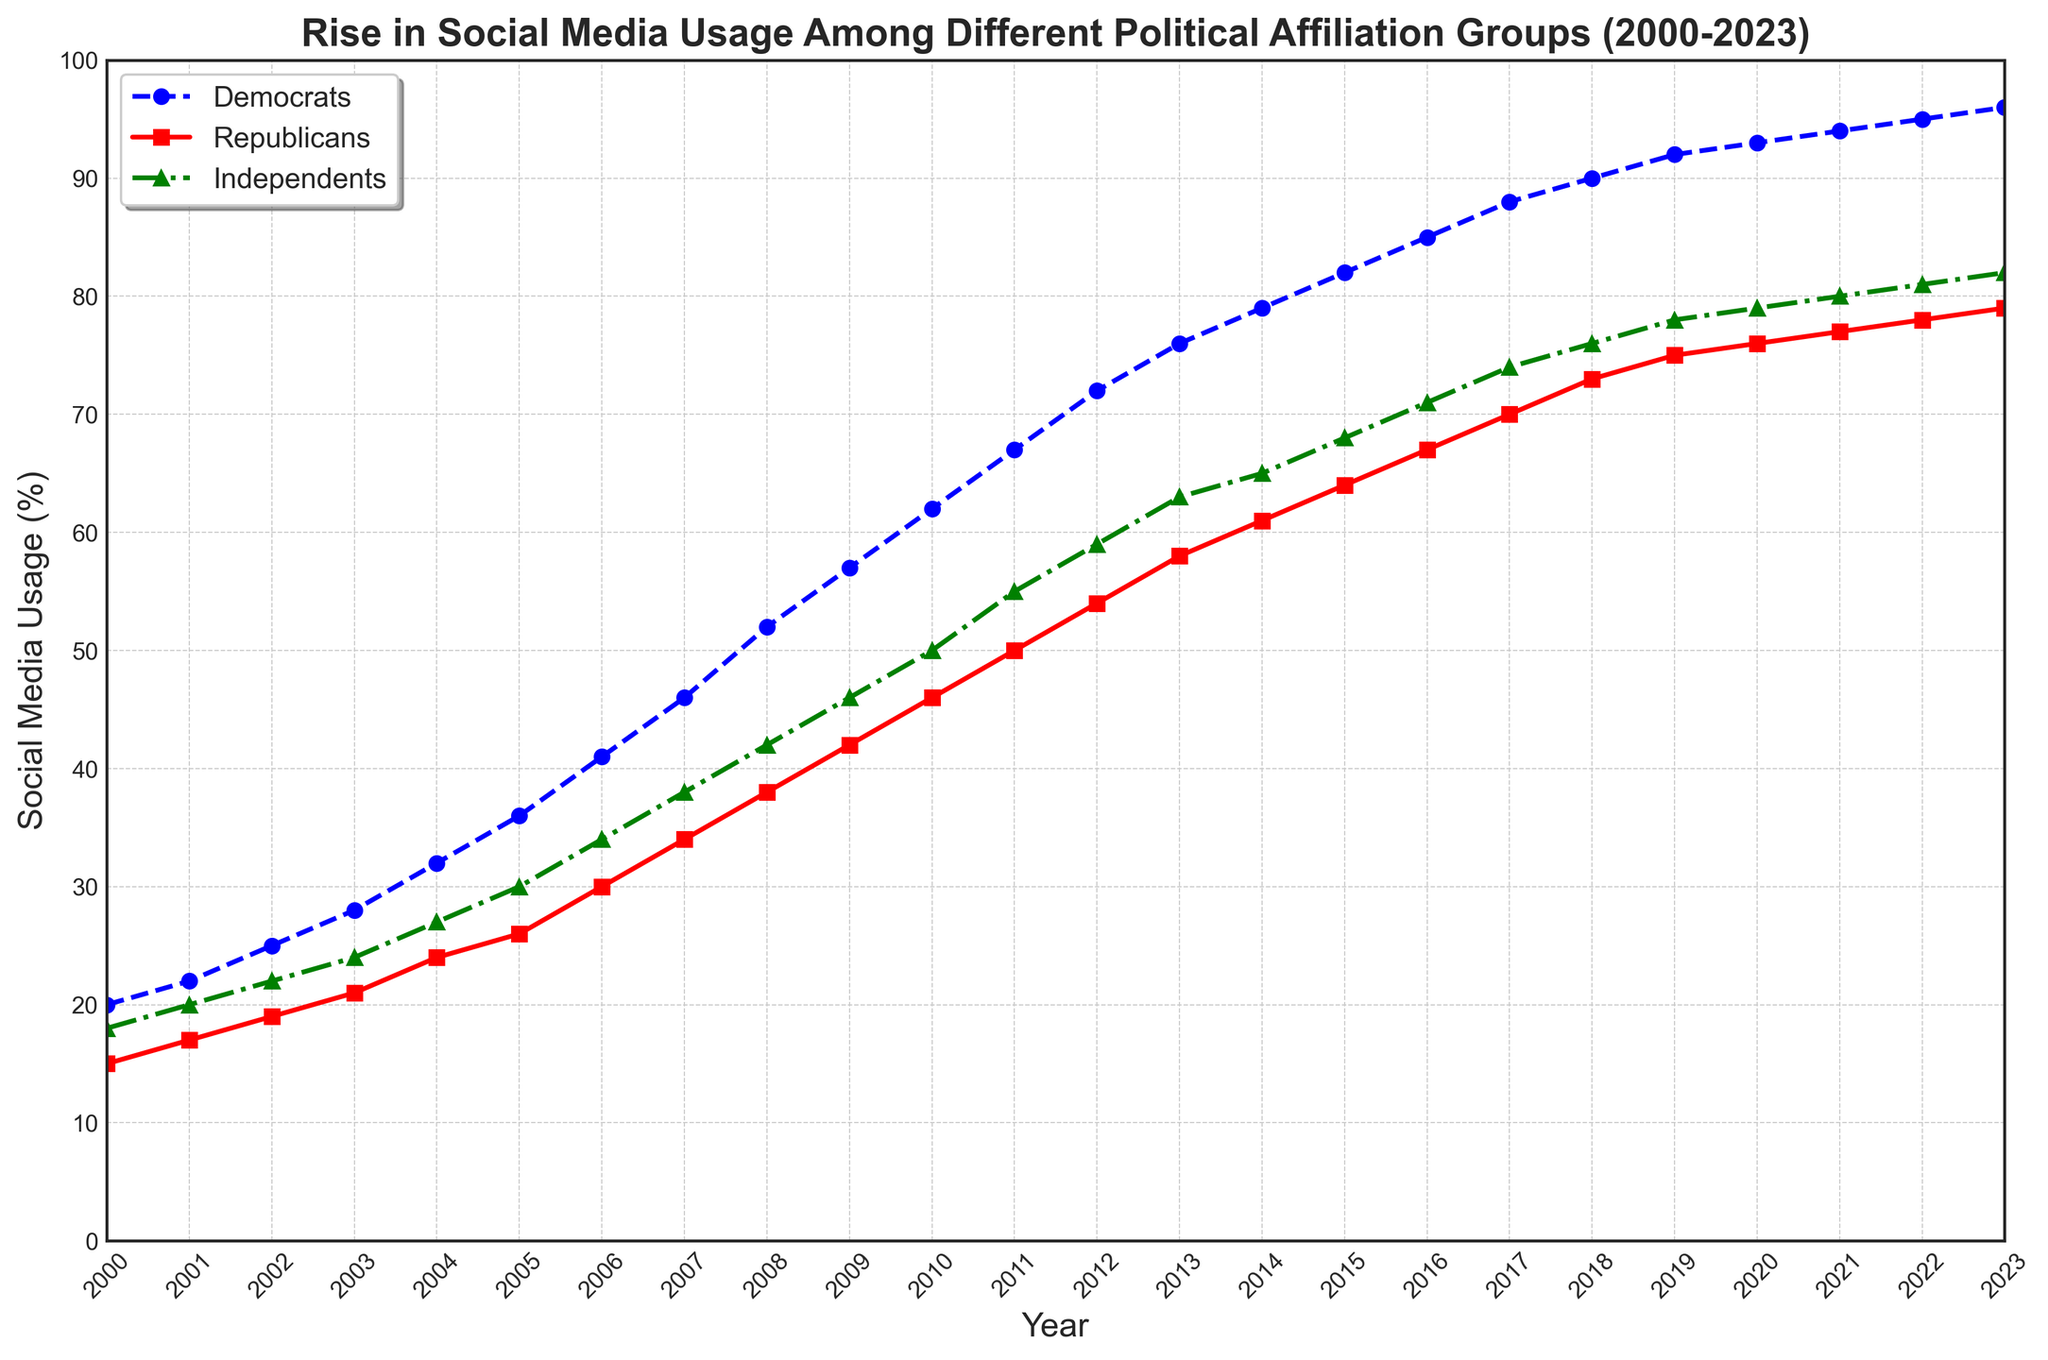What is the percentage increase in social media usage among Democrats from 2000 to 2023? To find the percentage increase, we need to calculate the difference in usage from 2000 to 2023 and then divide by the initial value. In 2000, the value is 20%, and in 2023, it's 96%. The increase is 96 - 20 = 76%. The percentage increase is (76 / 20) * 100 = 380%.
Answer: 380% In which year did Independents surpass a 50% social media usage rate? To find when Independents surpass 50%, we examine the values for each year. In 2011, the usage is 55%, which is the first time it is over 50%.
Answer: 2011 Between Democrats and Republicans, which group had a higher increase in social media usage from 2005 to 2015? We compare the increase for both groups between these years. For Democrats, in 2015 it is 82% and in 2005 it is 36%, so the increase is 82 - 36 = 46%. For Republicans, in 2015 it's 64% and in 2005 it is 26%, so the increase is 64 - 26 = 38%. Democrats have a higher increase.
Answer: Democrats What was the average social media usage of Republicans from 2000 to 2010? Calculate the average usage over the specified years. Sum the values (15 + 17 + 19 + 21 + 24 + 26 + 30 + 34 + 38 + 42 + 46) = 312, then divide by the number of years, 11. The average is 312 / 11 = 28.36%.
Answer: 28.36% How does the social media usage of Independents in 2020 compare to that in 2005? To compare, subtract the 2005 value from the 2020 value. In 2020 it's 79%, and in 2005 it's 30%. The difference is 79 - 30 = 49%.
Answer: 49% higher In which year did the Democrats reach social media usage of 70% or more? We need to find the first year when Democrats' usage is 70% or higher. In 2012, the value is 72%, meeting the criteria.
Answer: 2012 For which political group was the increase in social media usage from 2015 to 2023 the smallest? Calculate the increase for each group from 2015 to 2023. For Democrats: 96% - 82% = 14%. For Republicans: 79% - 64% = 15%. For Independents: 82% - 68% = 14%. Both Democrats and Independents had the smallest increase.
Answer: Democrats and Independents What was the difference in social media usage between Republicans and Independents in 2018? Subtract the percentage usage of Republicans from Independents for 2018. Independents' usage in 2018 is 76%, and Republicans' usage is 73%. The difference is 76 - 73 = 3%.
Answer: 3% Which group showed the fastest initial growth in social media usage from 2000 to 2005? Compare the growth of each group over these years. Democrats: 36% - 20% = 16%. Republicans: 26% - 15% = 11%. Independents: 30% - 18% = 12%. Democrats showed the fastest growth.
Answer: Democrats 